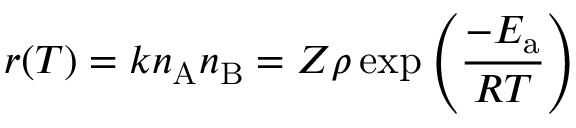<formula> <loc_0><loc_0><loc_500><loc_500>r ( T ) = k n _ { A } n _ { B } = Z \rho \exp \left ( { \frac { - E _ { a } } { R T } } \right )</formula> 